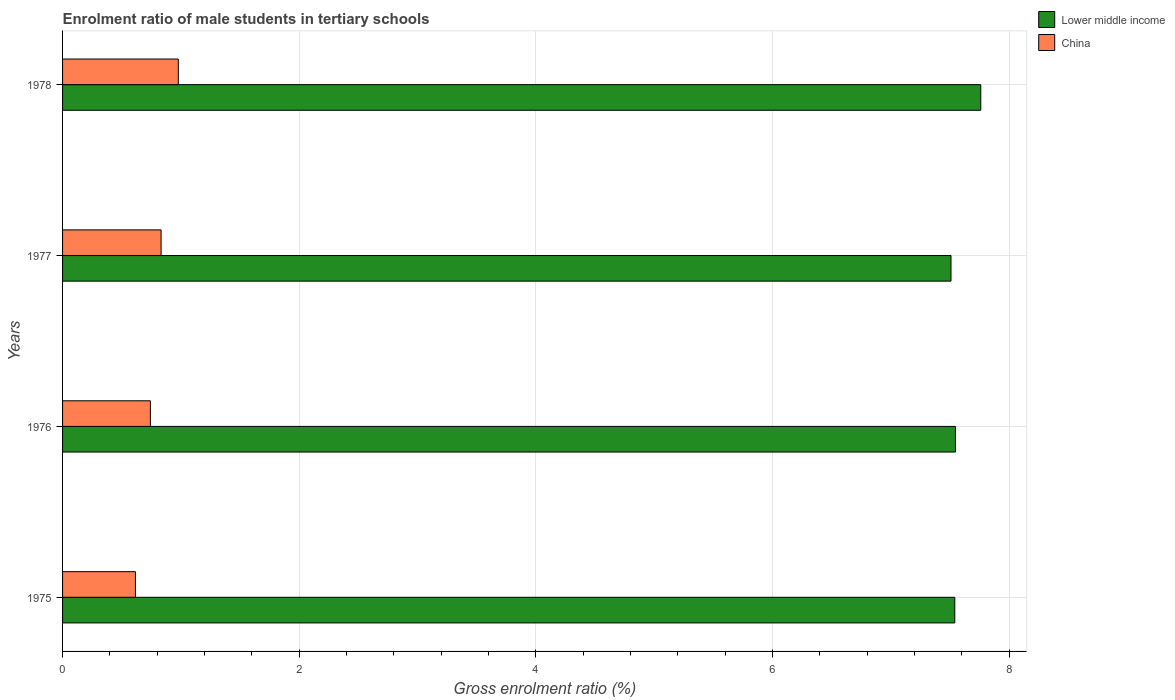How many different coloured bars are there?
Make the answer very short. 2. What is the label of the 4th group of bars from the top?
Your response must be concise. 1975. In how many cases, is the number of bars for a given year not equal to the number of legend labels?
Provide a short and direct response. 0. What is the enrolment ratio of male students in tertiary schools in China in 1978?
Provide a short and direct response. 0.98. Across all years, what is the maximum enrolment ratio of male students in tertiary schools in China?
Make the answer very short. 0.98. Across all years, what is the minimum enrolment ratio of male students in tertiary schools in China?
Offer a terse response. 0.62. In which year was the enrolment ratio of male students in tertiary schools in China maximum?
Your answer should be compact. 1978. In which year was the enrolment ratio of male students in tertiary schools in China minimum?
Give a very brief answer. 1975. What is the total enrolment ratio of male students in tertiary schools in China in the graph?
Ensure brevity in your answer.  3.17. What is the difference between the enrolment ratio of male students in tertiary schools in Lower middle income in 1976 and that in 1978?
Provide a short and direct response. -0.21. What is the difference between the enrolment ratio of male students in tertiary schools in Lower middle income in 1977 and the enrolment ratio of male students in tertiary schools in China in 1975?
Give a very brief answer. 6.89. What is the average enrolment ratio of male students in tertiary schools in China per year?
Ensure brevity in your answer.  0.79. In the year 1977, what is the difference between the enrolment ratio of male students in tertiary schools in China and enrolment ratio of male students in tertiary schools in Lower middle income?
Keep it short and to the point. -6.68. In how many years, is the enrolment ratio of male students in tertiary schools in China greater than 1.6 %?
Your answer should be compact. 0. What is the ratio of the enrolment ratio of male students in tertiary schools in China in 1975 to that in 1977?
Your answer should be compact. 0.74. Is the enrolment ratio of male students in tertiary schools in China in 1976 less than that in 1977?
Your response must be concise. Yes. Is the difference between the enrolment ratio of male students in tertiary schools in China in 1975 and 1978 greater than the difference between the enrolment ratio of male students in tertiary schools in Lower middle income in 1975 and 1978?
Provide a short and direct response. No. What is the difference between the highest and the second highest enrolment ratio of male students in tertiary schools in Lower middle income?
Ensure brevity in your answer.  0.21. What is the difference between the highest and the lowest enrolment ratio of male students in tertiary schools in Lower middle income?
Provide a short and direct response. 0.25. In how many years, is the enrolment ratio of male students in tertiary schools in Lower middle income greater than the average enrolment ratio of male students in tertiary schools in Lower middle income taken over all years?
Your answer should be very brief. 1. What does the 2nd bar from the top in 1978 represents?
Your answer should be compact. Lower middle income. What does the 1st bar from the bottom in 1976 represents?
Provide a succinct answer. Lower middle income. How many bars are there?
Provide a short and direct response. 8. Are all the bars in the graph horizontal?
Give a very brief answer. Yes. Are the values on the major ticks of X-axis written in scientific E-notation?
Provide a succinct answer. No. Does the graph contain grids?
Your answer should be very brief. Yes. How many legend labels are there?
Give a very brief answer. 2. How are the legend labels stacked?
Your answer should be compact. Vertical. What is the title of the graph?
Give a very brief answer. Enrolment ratio of male students in tertiary schools. What is the Gross enrolment ratio (%) in Lower middle income in 1975?
Your answer should be very brief. 7.54. What is the Gross enrolment ratio (%) in China in 1975?
Provide a short and direct response. 0.62. What is the Gross enrolment ratio (%) in Lower middle income in 1976?
Give a very brief answer. 7.55. What is the Gross enrolment ratio (%) in China in 1976?
Your answer should be compact. 0.74. What is the Gross enrolment ratio (%) of Lower middle income in 1977?
Give a very brief answer. 7.51. What is the Gross enrolment ratio (%) in China in 1977?
Your answer should be very brief. 0.83. What is the Gross enrolment ratio (%) in Lower middle income in 1978?
Keep it short and to the point. 7.76. What is the Gross enrolment ratio (%) in China in 1978?
Keep it short and to the point. 0.98. Across all years, what is the maximum Gross enrolment ratio (%) in Lower middle income?
Offer a terse response. 7.76. Across all years, what is the maximum Gross enrolment ratio (%) of China?
Your response must be concise. 0.98. Across all years, what is the minimum Gross enrolment ratio (%) in Lower middle income?
Provide a succinct answer. 7.51. Across all years, what is the minimum Gross enrolment ratio (%) in China?
Your answer should be very brief. 0.62. What is the total Gross enrolment ratio (%) of Lower middle income in the graph?
Your answer should be compact. 30.36. What is the total Gross enrolment ratio (%) of China in the graph?
Offer a very short reply. 3.17. What is the difference between the Gross enrolment ratio (%) of Lower middle income in 1975 and that in 1976?
Offer a very short reply. -0.01. What is the difference between the Gross enrolment ratio (%) of China in 1975 and that in 1976?
Ensure brevity in your answer.  -0.13. What is the difference between the Gross enrolment ratio (%) of Lower middle income in 1975 and that in 1977?
Offer a terse response. 0.03. What is the difference between the Gross enrolment ratio (%) of China in 1975 and that in 1977?
Your answer should be compact. -0.22. What is the difference between the Gross enrolment ratio (%) in Lower middle income in 1975 and that in 1978?
Provide a succinct answer. -0.22. What is the difference between the Gross enrolment ratio (%) of China in 1975 and that in 1978?
Your answer should be compact. -0.36. What is the difference between the Gross enrolment ratio (%) of Lower middle income in 1976 and that in 1977?
Your response must be concise. 0.04. What is the difference between the Gross enrolment ratio (%) in China in 1976 and that in 1977?
Offer a terse response. -0.09. What is the difference between the Gross enrolment ratio (%) in Lower middle income in 1976 and that in 1978?
Offer a very short reply. -0.21. What is the difference between the Gross enrolment ratio (%) of China in 1976 and that in 1978?
Provide a succinct answer. -0.24. What is the difference between the Gross enrolment ratio (%) in Lower middle income in 1977 and that in 1978?
Give a very brief answer. -0.25. What is the difference between the Gross enrolment ratio (%) in China in 1977 and that in 1978?
Your response must be concise. -0.15. What is the difference between the Gross enrolment ratio (%) of Lower middle income in 1975 and the Gross enrolment ratio (%) of China in 1976?
Keep it short and to the point. 6.8. What is the difference between the Gross enrolment ratio (%) of Lower middle income in 1975 and the Gross enrolment ratio (%) of China in 1977?
Offer a terse response. 6.71. What is the difference between the Gross enrolment ratio (%) of Lower middle income in 1975 and the Gross enrolment ratio (%) of China in 1978?
Your response must be concise. 6.56. What is the difference between the Gross enrolment ratio (%) of Lower middle income in 1976 and the Gross enrolment ratio (%) of China in 1977?
Give a very brief answer. 6.71. What is the difference between the Gross enrolment ratio (%) of Lower middle income in 1976 and the Gross enrolment ratio (%) of China in 1978?
Provide a short and direct response. 6.57. What is the difference between the Gross enrolment ratio (%) in Lower middle income in 1977 and the Gross enrolment ratio (%) in China in 1978?
Keep it short and to the point. 6.53. What is the average Gross enrolment ratio (%) of Lower middle income per year?
Give a very brief answer. 7.59. What is the average Gross enrolment ratio (%) of China per year?
Make the answer very short. 0.79. In the year 1975, what is the difference between the Gross enrolment ratio (%) in Lower middle income and Gross enrolment ratio (%) in China?
Your answer should be compact. 6.92. In the year 1976, what is the difference between the Gross enrolment ratio (%) of Lower middle income and Gross enrolment ratio (%) of China?
Your answer should be very brief. 6.8. In the year 1977, what is the difference between the Gross enrolment ratio (%) of Lower middle income and Gross enrolment ratio (%) of China?
Make the answer very short. 6.68. In the year 1978, what is the difference between the Gross enrolment ratio (%) of Lower middle income and Gross enrolment ratio (%) of China?
Your answer should be compact. 6.78. What is the ratio of the Gross enrolment ratio (%) of Lower middle income in 1975 to that in 1976?
Your response must be concise. 1. What is the ratio of the Gross enrolment ratio (%) of China in 1975 to that in 1976?
Offer a very short reply. 0.83. What is the ratio of the Gross enrolment ratio (%) of Lower middle income in 1975 to that in 1977?
Offer a terse response. 1. What is the ratio of the Gross enrolment ratio (%) of China in 1975 to that in 1977?
Make the answer very short. 0.74. What is the ratio of the Gross enrolment ratio (%) of Lower middle income in 1975 to that in 1978?
Your answer should be compact. 0.97. What is the ratio of the Gross enrolment ratio (%) in China in 1975 to that in 1978?
Offer a very short reply. 0.63. What is the ratio of the Gross enrolment ratio (%) in Lower middle income in 1976 to that in 1977?
Your answer should be compact. 1. What is the ratio of the Gross enrolment ratio (%) of China in 1976 to that in 1977?
Make the answer very short. 0.89. What is the ratio of the Gross enrolment ratio (%) of Lower middle income in 1976 to that in 1978?
Ensure brevity in your answer.  0.97. What is the ratio of the Gross enrolment ratio (%) in China in 1976 to that in 1978?
Provide a succinct answer. 0.76. What is the ratio of the Gross enrolment ratio (%) in Lower middle income in 1977 to that in 1978?
Your response must be concise. 0.97. What is the ratio of the Gross enrolment ratio (%) in China in 1977 to that in 1978?
Ensure brevity in your answer.  0.85. What is the difference between the highest and the second highest Gross enrolment ratio (%) of Lower middle income?
Your answer should be compact. 0.21. What is the difference between the highest and the second highest Gross enrolment ratio (%) in China?
Provide a succinct answer. 0.15. What is the difference between the highest and the lowest Gross enrolment ratio (%) in Lower middle income?
Make the answer very short. 0.25. What is the difference between the highest and the lowest Gross enrolment ratio (%) of China?
Keep it short and to the point. 0.36. 